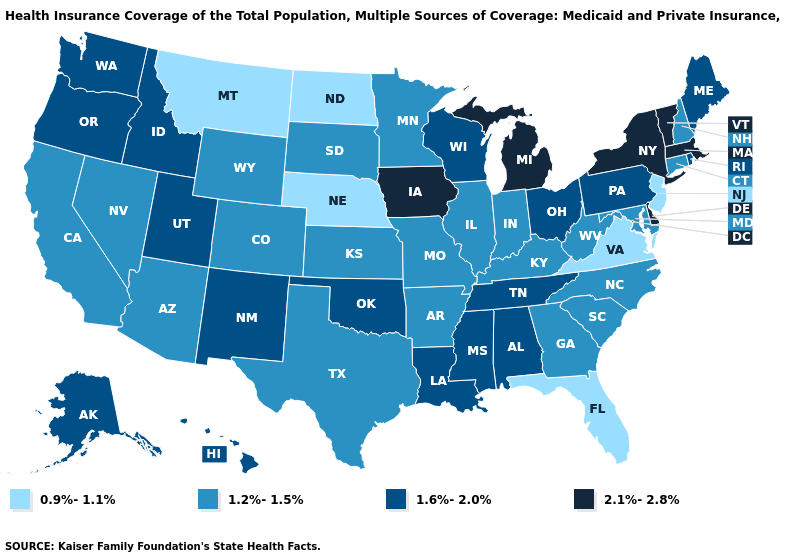Name the states that have a value in the range 2.1%-2.8%?
Be succinct. Delaware, Iowa, Massachusetts, Michigan, New York, Vermont. What is the value of South Carolina?
Keep it brief. 1.2%-1.5%. Does Virginia have the lowest value in the USA?
Short answer required. Yes. What is the lowest value in states that border Pennsylvania?
Give a very brief answer. 0.9%-1.1%. How many symbols are there in the legend?
Concise answer only. 4. What is the value of Iowa?
Answer briefly. 2.1%-2.8%. What is the value of Arizona?
Write a very short answer. 1.2%-1.5%. What is the value of Ohio?
Short answer required. 1.6%-2.0%. Does Vermont have the lowest value in the Northeast?
Concise answer only. No. Name the states that have a value in the range 1.6%-2.0%?
Keep it brief. Alabama, Alaska, Hawaii, Idaho, Louisiana, Maine, Mississippi, New Mexico, Ohio, Oklahoma, Oregon, Pennsylvania, Rhode Island, Tennessee, Utah, Washington, Wisconsin. What is the value of Arizona?
Write a very short answer. 1.2%-1.5%. Name the states that have a value in the range 2.1%-2.8%?
Give a very brief answer. Delaware, Iowa, Massachusetts, Michigan, New York, Vermont. Does New Mexico have a higher value than Maine?
Short answer required. No. Does Massachusetts have the highest value in the USA?
Quick response, please. Yes. 